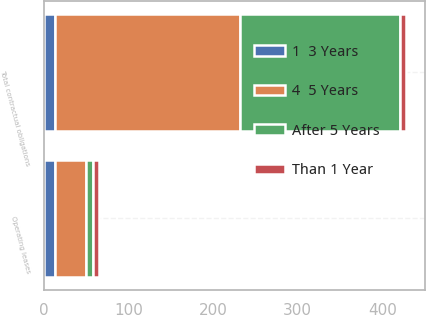<chart> <loc_0><loc_0><loc_500><loc_500><stacked_bar_chart><ecel><fcel>Operating leases<fcel>Total contractual obligations<nl><fcel>4  5 Years<fcel>36.9<fcel>218.6<nl><fcel>After 5 Years<fcel>8.3<fcel>190<nl><fcel>1  3 Years<fcel>12.7<fcel>12.7<nl><fcel>Than 1 Year<fcel>7.3<fcel>7.3<nl></chart> 